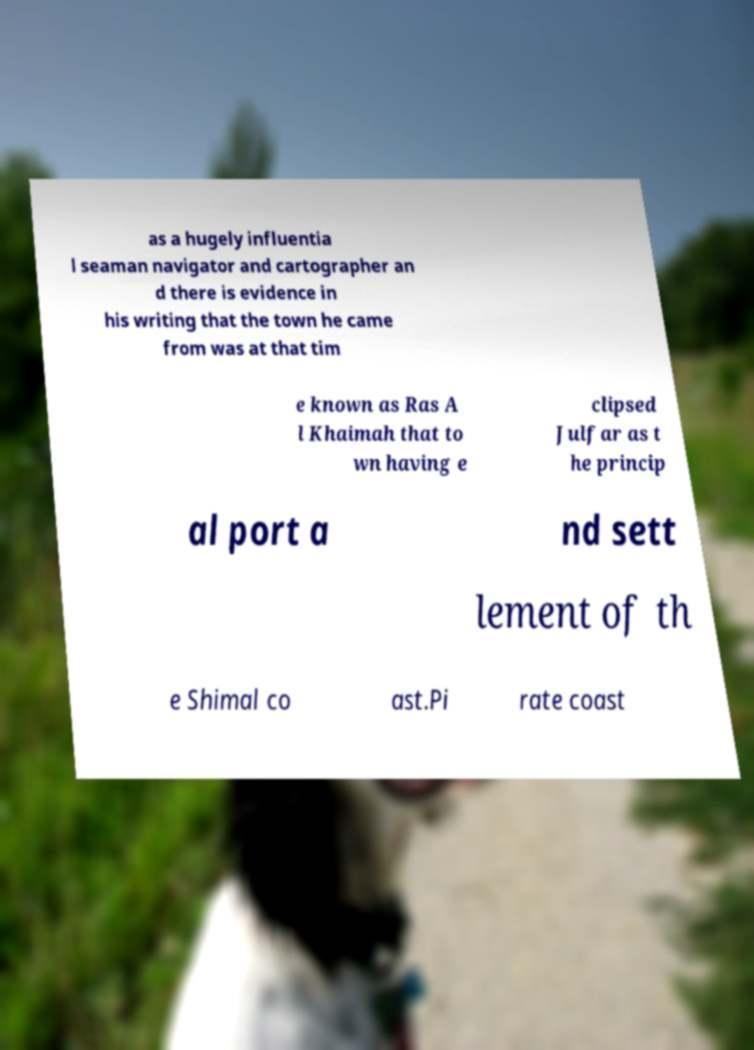There's text embedded in this image that I need extracted. Can you transcribe it verbatim? as a hugely influentia l seaman navigator and cartographer an d there is evidence in his writing that the town he came from was at that tim e known as Ras A l Khaimah that to wn having e clipsed Julfar as t he princip al port a nd sett lement of th e Shimal co ast.Pi rate coast 